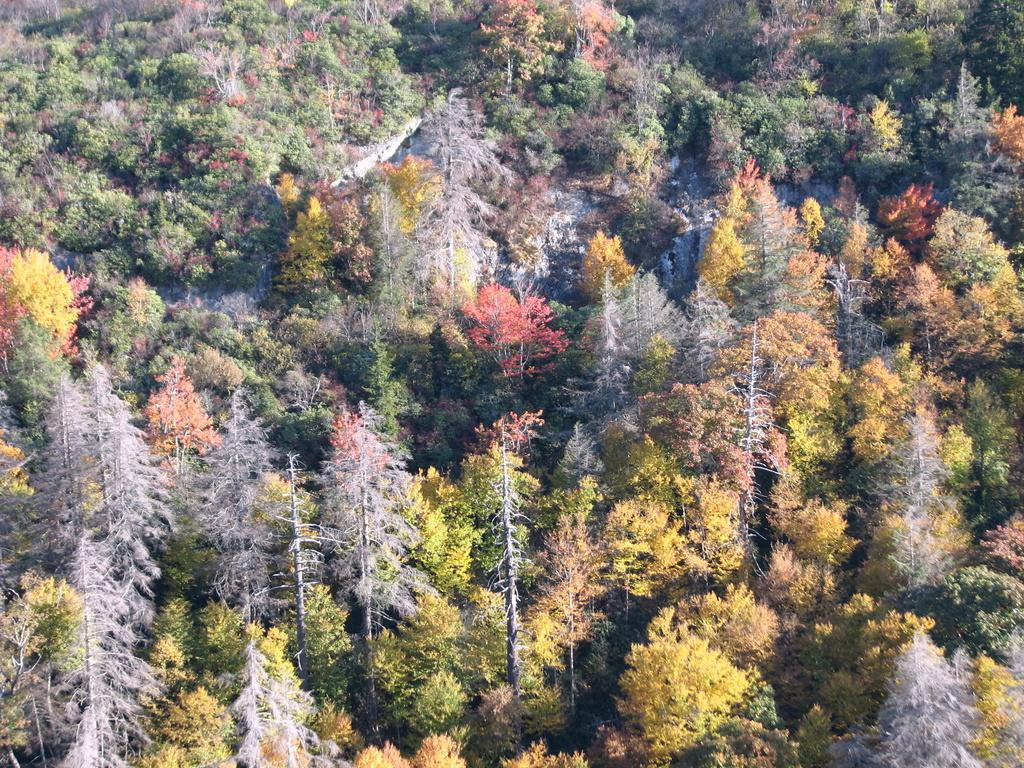What is the primary feature of the image? The primary feature of the image is the presence of many trees. Can you describe the colors of the trees in the image? The trees in the image have different colors, including white, yellow, green, and red. How does the cork affect the growth of the trees in the image? There is no mention of a cork in the image, so it cannot affect the growth of the trees. 